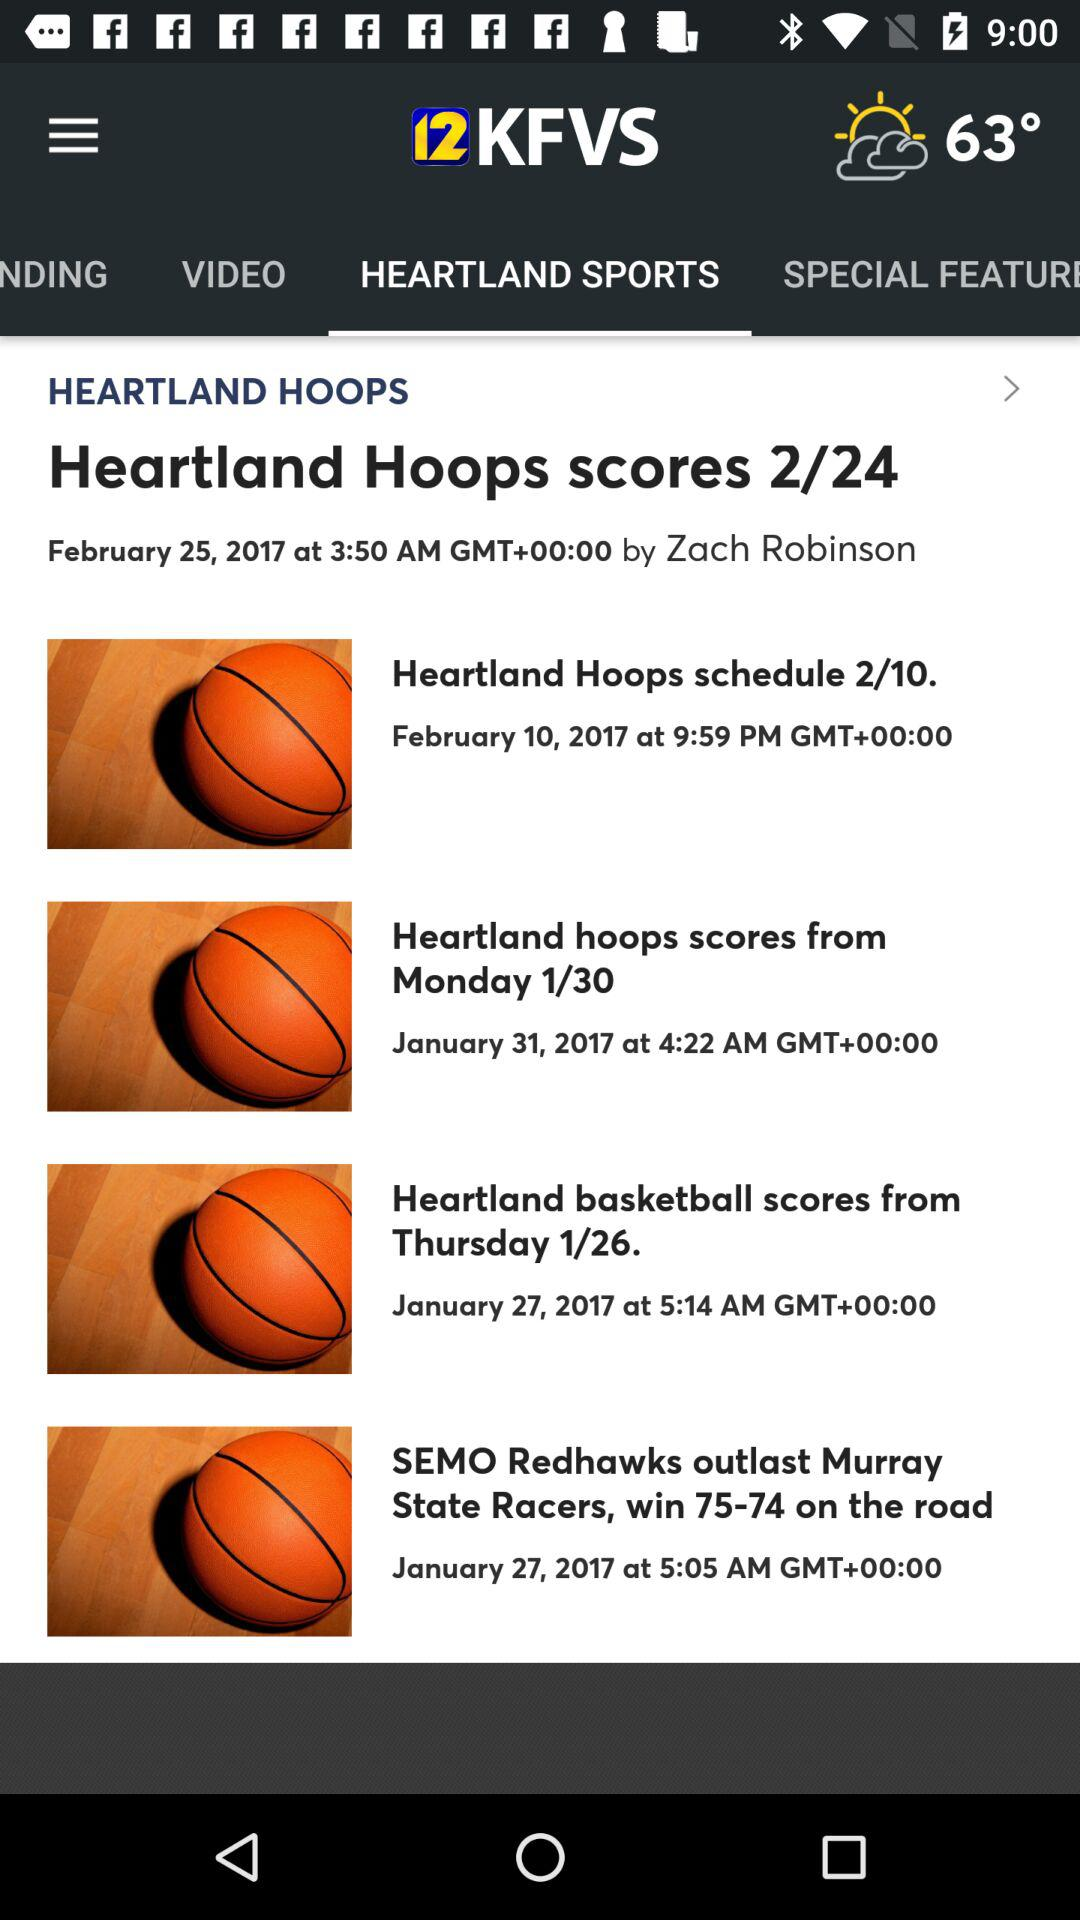What are the total scores?
When the provided information is insufficient, respond with <no answer>. <no answer> 